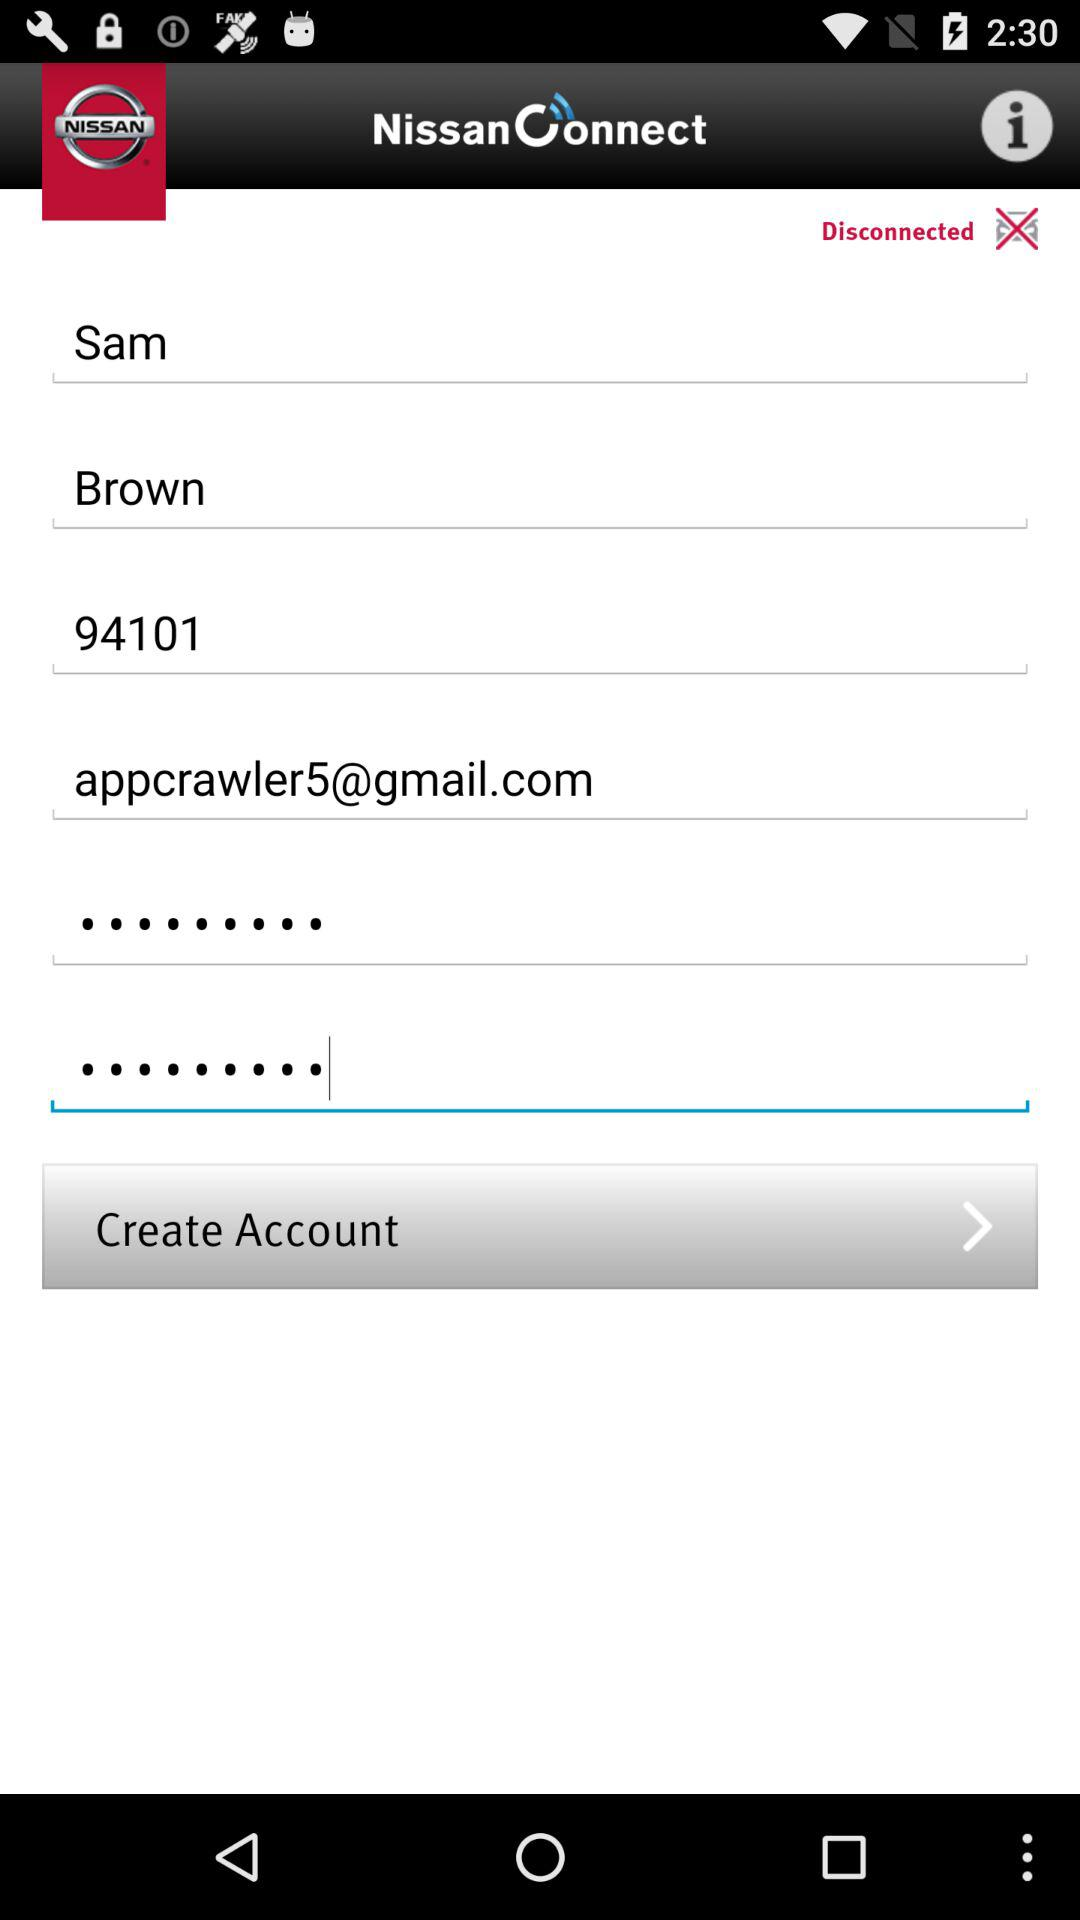What is the ZIP code? The ZIP code is 94101. 